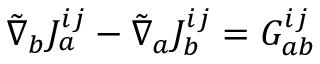Convert formula to latex. <formula><loc_0><loc_0><loc_500><loc_500>{ \tilde { \nabla } } _ { b } J _ { a } ^ { i j } - { \tilde { \nabla } } _ { a } J _ { b } ^ { i j } = G _ { a b } ^ { i j }</formula> 